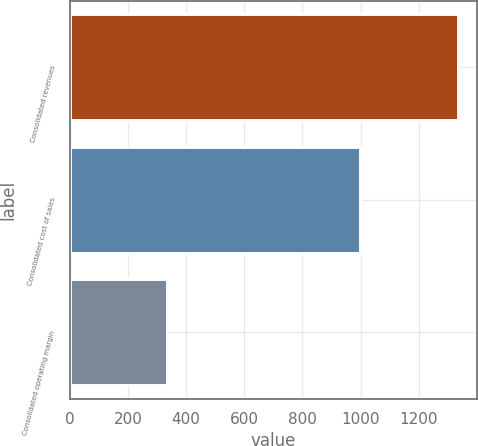Convert chart. <chart><loc_0><loc_0><loc_500><loc_500><bar_chart><fcel>Consolidated revenues<fcel>Consolidated cost of sales<fcel>Consolidated operating margin<nl><fcel>1333.3<fcel>997.7<fcel>335.6<nl></chart> 